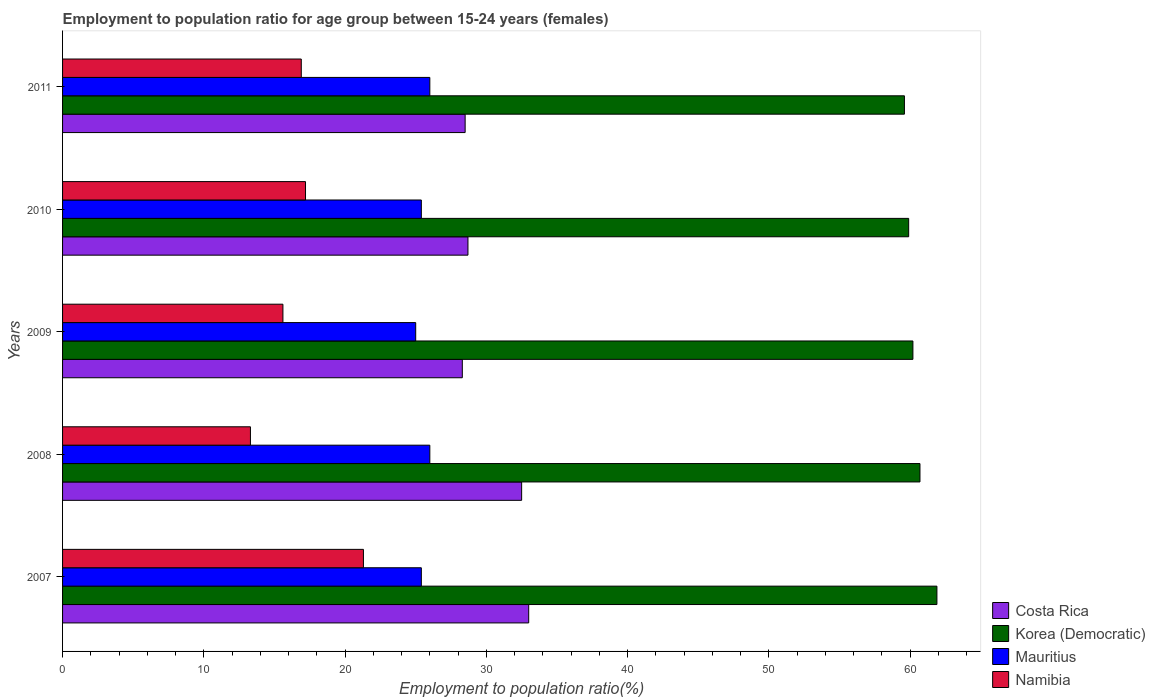How many different coloured bars are there?
Your response must be concise. 4. Are the number of bars per tick equal to the number of legend labels?
Provide a short and direct response. Yes. How many bars are there on the 5th tick from the top?
Offer a very short reply. 4. What is the label of the 1st group of bars from the top?
Keep it short and to the point. 2011. In how many cases, is the number of bars for a given year not equal to the number of legend labels?
Give a very brief answer. 0. What is the employment to population ratio in Mauritius in 2011?
Give a very brief answer. 26. Across all years, what is the maximum employment to population ratio in Namibia?
Offer a terse response. 21.3. Across all years, what is the minimum employment to population ratio in Costa Rica?
Provide a short and direct response. 28.3. In which year was the employment to population ratio in Mauritius minimum?
Offer a terse response. 2009. What is the total employment to population ratio in Namibia in the graph?
Provide a succinct answer. 84.3. What is the difference between the employment to population ratio in Namibia in 2009 and that in 2010?
Offer a terse response. -1.6. What is the difference between the employment to population ratio in Korea (Democratic) in 2010 and the employment to population ratio in Namibia in 2011?
Your answer should be compact. 43. What is the average employment to population ratio in Costa Rica per year?
Ensure brevity in your answer.  30.2. In the year 2008, what is the difference between the employment to population ratio in Costa Rica and employment to population ratio in Korea (Democratic)?
Ensure brevity in your answer.  -28.2. In how many years, is the employment to population ratio in Costa Rica greater than 60 %?
Offer a terse response. 0. What is the ratio of the employment to population ratio in Namibia in 2007 to that in 2010?
Provide a short and direct response. 1.24. What is the difference between the highest and the lowest employment to population ratio in Mauritius?
Your answer should be compact. 1. In how many years, is the employment to population ratio in Namibia greater than the average employment to population ratio in Namibia taken over all years?
Your response must be concise. 3. Is the sum of the employment to population ratio in Costa Rica in 2008 and 2009 greater than the maximum employment to population ratio in Mauritius across all years?
Keep it short and to the point. Yes. Is it the case that in every year, the sum of the employment to population ratio in Mauritius and employment to population ratio in Korea (Democratic) is greater than the sum of employment to population ratio in Namibia and employment to population ratio in Costa Rica?
Keep it short and to the point. No. What does the 3rd bar from the top in 2008 represents?
Offer a terse response. Korea (Democratic). What does the 4th bar from the bottom in 2009 represents?
Make the answer very short. Namibia. Is it the case that in every year, the sum of the employment to population ratio in Mauritius and employment to population ratio in Costa Rica is greater than the employment to population ratio in Korea (Democratic)?
Your answer should be compact. No. How many bars are there?
Offer a very short reply. 20. Are all the bars in the graph horizontal?
Your answer should be very brief. Yes. How many years are there in the graph?
Your answer should be compact. 5. Does the graph contain any zero values?
Give a very brief answer. No. Does the graph contain grids?
Your answer should be very brief. No. Where does the legend appear in the graph?
Offer a very short reply. Bottom right. How are the legend labels stacked?
Keep it short and to the point. Vertical. What is the title of the graph?
Make the answer very short. Employment to population ratio for age group between 15-24 years (females). What is the label or title of the X-axis?
Your answer should be compact. Employment to population ratio(%). What is the label or title of the Y-axis?
Your response must be concise. Years. What is the Employment to population ratio(%) in Korea (Democratic) in 2007?
Offer a very short reply. 61.9. What is the Employment to population ratio(%) in Mauritius in 2007?
Your response must be concise. 25.4. What is the Employment to population ratio(%) of Namibia in 2007?
Offer a terse response. 21.3. What is the Employment to population ratio(%) in Costa Rica in 2008?
Your response must be concise. 32.5. What is the Employment to population ratio(%) in Korea (Democratic) in 2008?
Make the answer very short. 60.7. What is the Employment to population ratio(%) in Mauritius in 2008?
Ensure brevity in your answer.  26. What is the Employment to population ratio(%) of Namibia in 2008?
Keep it short and to the point. 13.3. What is the Employment to population ratio(%) of Costa Rica in 2009?
Make the answer very short. 28.3. What is the Employment to population ratio(%) of Korea (Democratic) in 2009?
Offer a very short reply. 60.2. What is the Employment to population ratio(%) of Mauritius in 2009?
Ensure brevity in your answer.  25. What is the Employment to population ratio(%) in Namibia in 2009?
Your response must be concise. 15.6. What is the Employment to population ratio(%) of Costa Rica in 2010?
Your response must be concise. 28.7. What is the Employment to population ratio(%) of Korea (Democratic) in 2010?
Give a very brief answer. 59.9. What is the Employment to population ratio(%) in Mauritius in 2010?
Your response must be concise. 25.4. What is the Employment to population ratio(%) of Namibia in 2010?
Provide a short and direct response. 17.2. What is the Employment to population ratio(%) of Korea (Democratic) in 2011?
Your answer should be very brief. 59.6. What is the Employment to population ratio(%) in Namibia in 2011?
Ensure brevity in your answer.  16.9. Across all years, what is the maximum Employment to population ratio(%) of Korea (Democratic)?
Give a very brief answer. 61.9. Across all years, what is the maximum Employment to population ratio(%) in Namibia?
Your response must be concise. 21.3. Across all years, what is the minimum Employment to population ratio(%) in Costa Rica?
Offer a very short reply. 28.3. Across all years, what is the minimum Employment to population ratio(%) of Korea (Democratic)?
Keep it short and to the point. 59.6. Across all years, what is the minimum Employment to population ratio(%) in Namibia?
Your answer should be compact. 13.3. What is the total Employment to population ratio(%) in Costa Rica in the graph?
Give a very brief answer. 151. What is the total Employment to population ratio(%) in Korea (Democratic) in the graph?
Provide a succinct answer. 302.3. What is the total Employment to population ratio(%) of Mauritius in the graph?
Your answer should be very brief. 127.8. What is the total Employment to population ratio(%) in Namibia in the graph?
Keep it short and to the point. 84.3. What is the difference between the Employment to population ratio(%) in Korea (Democratic) in 2007 and that in 2008?
Ensure brevity in your answer.  1.2. What is the difference between the Employment to population ratio(%) in Korea (Democratic) in 2007 and that in 2009?
Ensure brevity in your answer.  1.7. What is the difference between the Employment to population ratio(%) in Korea (Democratic) in 2007 and that in 2010?
Offer a terse response. 2. What is the difference between the Employment to population ratio(%) in Mauritius in 2007 and that in 2010?
Offer a terse response. 0. What is the difference between the Employment to population ratio(%) of Mauritius in 2007 and that in 2011?
Offer a terse response. -0.6. What is the difference between the Employment to population ratio(%) in Korea (Democratic) in 2008 and that in 2009?
Give a very brief answer. 0.5. What is the difference between the Employment to population ratio(%) of Mauritius in 2008 and that in 2009?
Make the answer very short. 1. What is the difference between the Employment to population ratio(%) in Namibia in 2008 and that in 2009?
Provide a short and direct response. -2.3. What is the difference between the Employment to population ratio(%) of Namibia in 2008 and that in 2010?
Your response must be concise. -3.9. What is the difference between the Employment to population ratio(%) in Korea (Democratic) in 2008 and that in 2011?
Keep it short and to the point. 1.1. What is the difference between the Employment to population ratio(%) in Namibia in 2008 and that in 2011?
Provide a succinct answer. -3.6. What is the difference between the Employment to population ratio(%) in Korea (Democratic) in 2009 and that in 2010?
Ensure brevity in your answer.  0.3. What is the difference between the Employment to population ratio(%) of Mauritius in 2009 and that in 2010?
Give a very brief answer. -0.4. What is the difference between the Employment to population ratio(%) of Costa Rica in 2009 and that in 2011?
Ensure brevity in your answer.  -0.2. What is the difference between the Employment to population ratio(%) of Namibia in 2009 and that in 2011?
Give a very brief answer. -1.3. What is the difference between the Employment to population ratio(%) of Korea (Democratic) in 2010 and that in 2011?
Keep it short and to the point. 0.3. What is the difference between the Employment to population ratio(%) of Costa Rica in 2007 and the Employment to population ratio(%) of Korea (Democratic) in 2008?
Your answer should be compact. -27.7. What is the difference between the Employment to population ratio(%) in Costa Rica in 2007 and the Employment to population ratio(%) in Mauritius in 2008?
Provide a short and direct response. 7. What is the difference between the Employment to population ratio(%) of Korea (Democratic) in 2007 and the Employment to population ratio(%) of Mauritius in 2008?
Provide a succinct answer. 35.9. What is the difference between the Employment to population ratio(%) of Korea (Democratic) in 2007 and the Employment to population ratio(%) of Namibia in 2008?
Ensure brevity in your answer.  48.6. What is the difference between the Employment to population ratio(%) in Mauritius in 2007 and the Employment to population ratio(%) in Namibia in 2008?
Give a very brief answer. 12.1. What is the difference between the Employment to population ratio(%) in Costa Rica in 2007 and the Employment to population ratio(%) in Korea (Democratic) in 2009?
Provide a short and direct response. -27.2. What is the difference between the Employment to population ratio(%) in Korea (Democratic) in 2007 and the Employment to population ratio(%) in Mauritius in 2009?
Your answer should be very brief. 36.9. What is the difference between the Employment to population ratio(%) of Korea (Democratic) in 2007 and the Employment to population ratio(%) of Namibia in 2009?
Give a very brief answer. 46.3. What is the difference between the Employment to population ratio(%) of Mauritius in 2007 and the Employment to population ratio(%) of Namibia in 2009?
Ensure brevity in your answer.  9.8. What is the difference between the Employment to population ratio(%) of Costa Rica in 2007 and the Employment to population ratio(%) of Korea (Democratic) in 2010?
Your answer should be very brief. -26.9. What is the difference between the Employment to population ratio(%) of Costa Rica in 2007 and the Employment to population ratio(%) of Mauritius in 2010?
Make the answer very short. 7.6. What is the difference between the Employment to population ratio(%) in Costa Rica in 2007 and the Employment to population ratio(%) in Namibia in 2010?
Provide a short and direct response. 15.8. What is the difference between the Employment to population ratio(%) of Korea (Democratic) in 2007 and the Employment to population ratio(%) of Mauritius in 2010?
Give a very brief answer. 36.5. What is the difference between the Employment to population ratio(%) of Korea (Democratic) in 2007 and the Employment to population ratio(%) of Namibia in 2010?
Keep it short and to the point. 44.7. What is the difference between the Employment to population ratio(%) of Mauritius in 2007 and the Employment to population ratio(%) of Namibia in 2010?
Make the answer very short. 8.2. What is the difference between the Employment to population ratio(%) in Costa Rica in 2007 and the Employment to population ratio(%) in Korea (Democratic) in 2011?
Make the answer very short. -26.6. What is the difference between the Employment to population ratio(%) in Costa Rica in 2007 and the Employment to population ratio(%) in Namibia in 2011?
Offer a very short reply. 16.1. What is the difference between the Employment to population ratio(%) in Korea (Democratic) in 2007 and the Employment to population ratio(%) in Mauritius in 2011?
Your answer should be very brief. 35.9. What is the difference between the Employment to population ratio(%) of Mauritius in 2007 and the Employment to population ratio(%) of Namibia in 2011?
Your answer should be compact. 8.5. What is the difference between the Employment to population ratio(%) of Costa Rica in 2008 and the Employment to population ratio(%) of Korea (Democratic) in 2009?
Give a very brief answer. -27.7. What is the difference between the Employment to population ratio(%) of Costa Rica in 2008 and the Employment to population ratio(%) of Mauritius in 2009?
Offer a terse response. 7.5. What is the difference between the Employment to population ratio(%) in Costa Rica in 2008 and the Employment to population ratio(%) in Namibia in 2009?
Your answer should be compact. 16.9. What is the difference between the Employment to population ratio(%) in Korea (Democratic) in 2008 and the Employment to population ratio(%) in Mauritius in 2009?
Provide a short and direct response. 35.7. What is the difference between the Employment to population ratio(%) in Korea (Democratic) in 2008 and the Employment to population ratio(%) in Namibia in 2009?
Ensure brevity in your answer.  45.1. What is the difference between the Employment to population ratio(%) in Mauritius in 2008 and the Employment to population ratio(%) in Namibia in 2009?
Offer a terse response. 10.4. What is the difference between the Employment to population ratio(%) of Costa Rica in 2008 and the Employment to population ratio(%) of Korea (Democratic) in 2010?
Ensure brevity in your answer.  -27.4. What is the difference between the Employment to population ratio(%) of Costa Rica in 2008 and the Employment to population ratio(%) of Mauritius in 2010?
Your answer should be very brief. 7.1. What is the difference between the Employment to population ratio(%) of Costa Rica in 2008 and the Employment to population ratio(%) of Namibia in 2010?
Offer a terse response. 15.3. What is the difference between the Employment to population ratio(%) in Korea (Democratic) in 2008 and the Employment to population ratio(%) in Mauritius in 2010?
Your response must be concise. 35.3. What is the difference between the Employment to population ratio(%) in Korea (Democratic) in 2008 and the Employment to population ratio(%) in Namibia in 2010?
Give a very brief answer. 43.5. What is the difference between the Employment to population ratio(%) in Costa Rica in 2008 and the Employment to population ratio(%) in Korea (Democratic) in 2011?
Make the answer very short. -27.1. What is the difference between the Employment to population ratio(%) in Costa Rica in 2008 and the Employment to population ratio(%) in Mauritius in 2011?
Provide a succinct answer. 6.5. What is the difference between the Employment to population ratio(%) of Costa Rica in 2008 and the Employment to population ratio(%) of Namibia in 2011?
Your response must be concise. 15.6. What is the difference between the Employment to population ratio(%) of Korea (Democratic) in 2008 and the Employment to population ratio(%) of Mauritius in 2011?
Make the answer very short. 34.7. What is the difference between the Employment to population ratio(%) in Korea (Democratic) in 2008 and the Employment to population ratio(%) in Namibia in 2011?
Make the answer very short. 43.8. What is the difference between the Employment to population ratio(%) in Mauritius in 2008 and the Employment to population ratio(%) in Namibia in 2011?
Offer a terse response. 9.1. What is the difference between the Employment to population ratio(%) in Costa Rica in 2009 and the Employment to population ratio(%) in Korea (Democratic) in 2010?
Provide a short and direct response. -31.6. What is the difference between the Employment to population ratio(%) of Costa Rica in 2009 and the Employment to population ratio(%) of Mauritius in 2010?
Ensure brevity in your answer.  2.9. What is the difference between the Employment to population ratio(%) of Korea (Democratic) in 2009 and the Employment to population ratio(%) of Mauritius in 2010?
Provide a succinct answer. 34.8. What is the difference between the Employment to population ratio(%) in Korea (Democratic) in 2009 and the Employment to population ratio(%) in Namibia in 2010?
Make the answer very short. 43. What is the difference between the Employment to population ratio(%) in Costa Rica in 2009 and the Employment to population ratio(%) in Korea (Democratic) in 2011?
Keep it short and to the point. -31.3. What is the difference between the Employment to population ratio(%) of Korea (Democratic) in 2009 and the Employment to population ratio(%) of Mauritius in 2011?
Your answer should be very brief. 34.2. What is the difference between the Employment to population ratio(%) of Korea (Democratic) in 2009 and the Employment to population ratio(%) of Namibia in 2011?
Your response must be concise. 43.3. What is the difference between the Employment to population ratio(%) of Costa Rica in 2010 and the Employment to population ratio(%) of Korea (Democratic) in 2011?
Offer a very short reply. -30.9. What is the difference between the Employment to population ratio(%) of Korea (Democratic) in 2010 and the Employment to population ratio(%) of Mauritius in 2011?
Provide a short and direct response. 33.9. What is the difference between the Employment to population ratio(%) in Korea (Democratic) in 2010 and the Employment to population ratio(%) in Namibia in 2011?
Your response must be concise. 43. What is the average Employment to population ratio(%) in Costa Rica per year?
Provide a short and direct response. 30.2. What is the average Employment to population ratio(%) of Korea (Democratic) per year?
Your response must be concise. 60.46. What is the average Employment to population ratio(%) in Mauritius per year?
Ensure brevity in your answer.  25.56. What is the average Employment to population ratio(%) of Namibia per year?
Ensure brevity in your answer.  16.86. In the year 2007, what is the difference between the Employment to population ratio(%) in Costa Rica and Employment to population ratio(%) in Korea (Democratic)?
Provide a succinct answer. -28.9. In the year 2007, what is the difference between the Employment to population ratio(%) of Costa Rica and Employment to population ratio(%) of Mauritius?
Keep it short and to the point. 7.6. In the year 2007, what is the difference between the Employment to population ratio(%) in Costa Rica and Employment to population ratio(%) in Namibia?
Provide a succinct answer. 11.7. In the year 2007, what is the difference between the Employment to population ratio(%) in Korea (Democratic) and Employment to population ratio(%) in Mauritius?
Ensure brevity in your answer.  36.5. In the year 2007, what is the difference between the Employment to population ratio(%) in Korea (Democratic) and Employment to population ratio(%) in Namibia?
Your answer should be compact. 40.6. In the year 2008, what is the difference between the Employment to population ratio(%) of Costa Rica and Employment to population ratio(%) of Korea (Democratic)?
Offer a very short reply. -28.2. In the year 2008, what is the difference between the Employment to population ratio(%) of Costa Rica and Employment to population ratio(%) of Namibia?
Offer a very short reply. 19.2. In the year 2008, what is the difference between the Employment to population ratio(%) in Korea (Democratic) and Employment to population ratio(%) in Mauritius?
Your answer should be very brief. 34.7. In the year 2008, what is the difference between the Employment to population ratio(%) of Korea (Democratic) and Employment to population ratio(%) of Namibia?
Offer a very short reply. 47.4. In the year 2009, what is the difference between the Employment to population ratio(%) of Costa Rica and Employment to population ratio(%) of Korea (Democratic)?
Make the answer very short. -31.9. In the year 2009, what is the difference between the Employment to population ratio(%) of Costa Rica and Employment to population ratio(%) of Mauritius?
Offer a terse response. 3.3. In the year 2009, what is the difference between the Employment to population ratio(%) of Costa Rica and Employment to population ratio(%) of Namibia?
Give a very brief answer. 12.7. In the year 2009, what is the difference between the Employment to population ratio(%) of Korea (Democratic) and Employment to population ratio(%) of Mauritius?
Ensure brevity in your answer.  35.2. In the year 2009, what is the difference between the Employment to population ratio(%) of Korea (Democratic) and Employment to population ratio(%) of Namibia?
Your answer should be very brief. 44.6. In the year 2009, what is the difference between the Employment to population ratio(%) in Mauritius and Employment to population ratio(%) in Namibia?
Your response must be concise. 9.4. In the year 2010, what is the difference between the Employment to population ratio(%) in Costa Rica and Employment to population ratio(%) in Korea (Democratic)?
Keep it short and to the point. -31.2. In the year 2010, what is the difference between the Employment to population ratio(%) of Costa Rica and Employment to population ratio(%) of Namibia?
Your answer should be very brief. 11.5. In the year 2010, what is the difference between the Employment to population ratio(%) of Korea (Democratic) and Employment to population ratio(%) of Mauritius?
Make the answer very short. 34.5. In the year 2010, what is the difference between the Employment to population ratio(%) in Korea (Democratic) and Employment to population ratio(%) in Namibia?
Your response must be concise. 42.7. In the year 2010, what is the difference between the Employment to population ratio(%) of Mauritius and Employment to population ratio(%) of Namibia?
Provide a succinct answer. 8.2. In the year 2011, what is the difference between the Employment to population ratio(%) of Costa Rica and Employment to population ratio(%) of Korea (Democratic)?
Ensure brevity in your answer.  -31.1. In the year 2011, what is the difference between the Employment to population ratio(%) in Costa Rica and Employment to population ratio(%) in Namibia?
Your answer should be very brief. 11.6. In the year 2011, what is the difference between the Employment to population ratio(%) in Korea (Democratic) and Employment to population ratio(%) in Mauritius?
Your answer should be very brief. 33.6. In the year 2011, what is the difference between the Employment to population ratio(%) in Korea (Democratic) and Employment to population ratio(%) in Namibia?
Make the answer very short. 42.7. What is the ratio of the Employment to population ratio(%) of Costa Rica in 2007 to that in 2008?
Offer a terse response. 1.02. What is the ratio of the Employment to population ratio(%) in Korea (Democratic) in 2007 to that in 2008?
Your answer should be compact. 1.02. What is the ratio of the Employment to population ratio(%) of Mauritius in 2007 to that in 2008?
Your answer should be very brief. 0.98. What is the ratio of the Employment to population ratio(%) of Namibia in 2007 to that in 2008?
Make the answer very short. 1.6. What is the ratio of the Employment to population ratio(%) of Costa Rica in 2007 to that in 2009?
Ensure brevity in your answer.  1.17. What is the ratio of the Employment to population ratio(%) in Korea (Democratic) in 2007 to that in 2009?
Offer a terse response. 1.03. What is the ratio of the Employment to population ratio(%) of Mauritius in 2007 to that in 2009?
Offer a terse response. 1.02. What is the ratio of the Employment to population ratio(%) in Namibia in 2007 to that in 2009?
Keep it short and to the point. 1.37. What is the ratio of the Employment to population ratio(%) of Costa Rica in 2007 to that in 2010?
Your answer should be very brief. 1.15. What is the ratio of the Employment to population ratio(%) of Korea (Democratic) in 2007 to that in 2010?
Your response must be concise. 1.03. What is the ratio of the Employment to population ratio(%) in Mauritius in 2007 to that in 2010?
Offer a very short reply. 1. What is the ratio of the Employment to population ratio(%) of Namibia in 2007 to that in 2010?
Keep it short and to the point. 1.24. What is the ratio of the Employment to population ratio(%) in Costa Rica in 2007 to that in 2011?
Give a very brief answer. 1.16. What is the ratio of the Employment to population ratio(%) in Korea (Democratic) in 2007 to that in 2011?
Make the answer very short. 1.04. What is the ratio of the Employment to population ratio(%) in Mauritius in 2007 to that in 2011?
Offer a very short reply. 0.98. What is the ratio of the Employment to population ratio(%) in Namibia in 2007 to that in 2011?
Your answer should be very brief. 1.26. What is the ratio of the Employment to population ratio(%) of Costa Rica in 2008 to that in 2009?
Provide a succinct answer. 1.15. What is the ratio of the Employment to population ratio(%) in Korea (Democratic) in 2008 to that in 2009?
Keep it short and to the point. 1.01. What is the ratio of the Employment to population ratio(%) of Namibia in 2008 to that in 2009?
Keep it short and to the point. 0.85. What is the ratio of the Employment to population ratio(%) of Costa Rica in 2008 to that in 2010?
Offer a terse response. 1.13. What is the ratio of the Employment to population ratio(%) in Korea (Democratic) in 2008 to that in 2010?
Keep it short and to the point. 1.01. What is the ratio of the Employment to population ratio(%) in Mauritius in 2008 to that in 2010?
Offer a very short reply. 1.02. What is the ratio of the Employment to population ratio(%) of Namibia in 2008 to that in 2010?
Provide a succinct answer. 0.77. What is the ratio of the Employment to population ratio(%) of Costa Rica in 2008 to that in 2011?
Provide a succinct answer. 1.14. What is the ratio of the Employment to population ratio(%) of Korea (Democratic) in 2008 to that in 2011?
Your answer should be compact. 1.02. What is the ratio of the Employment to population ratio(%) in Mauritius in 2008 to that in 2011?
Give a very brief answer. 1. What is the ratio of the Employment to population ratio(%) of Namibia in 2008 to that in 2011?
Keep it short and to the point. 0.79. What is the ratio of the Employment to population ratio(%) in Costa Rica in 2009 to that in 2010?
Your response must be concise. 0.99. What is the ratio of the Employment to population ratio(%) of Mauritius in 2009 to that in 2010?
Keep it short and to the point. 0.98. What is the ratio of the Employment to population ratio(%) of Namibia in 2009 to that in 2010?
Your answer should be very brief. 0.91. What is the ratio of the Employment to population ratio(%) of Korea (Democratic) in 2009 to that in 2011?
Your answer should be compact. 1.01. What is the ratio of the Employment to population ratio(%) in Mauritius in 2009 to that in 2011?
Ensure brevity in your answer.  0.96. What is the ratio of the Employment to population ratio(%) in Namibia in 2009 to that in 2011?
Provide a succinct answer. 0.92. What is the ratio of the Employment to population ratio(%) of Mauritius in 2010 to that in 2011?
Provide a short and direct response. 0.98. What is the ratio of the Employment to population ratio(%) of Namibia in 2010 to that in 2011?
Keep it short and to the point. 1.02. What is the difference between the highest and the second highest Employment to population ratio(%) in Costa Rica?
Keep it short and to the point. 0.5. What is the difference between the highest and the second highest Employment to population ratio(%) of Korea (Democratic)?
Your response must be concise. 1.2. What is the difference between the highest and the second highest Employment to population ratio(%) of Mauritius?
Ensure brevity in your answer.  0. What is the difference between the highest and the lowest Employment to population ratio(%) of Mauritius?
Provide a succinct answer. 1. 